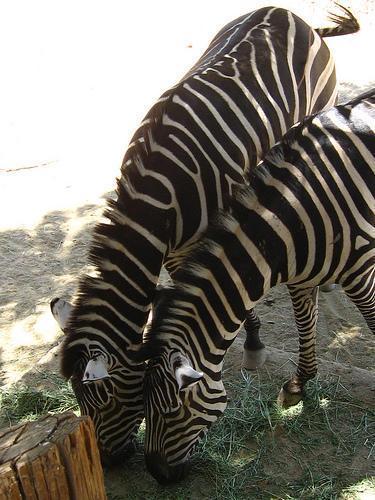How many zebras are there?
Give a very brief answer. 2. 